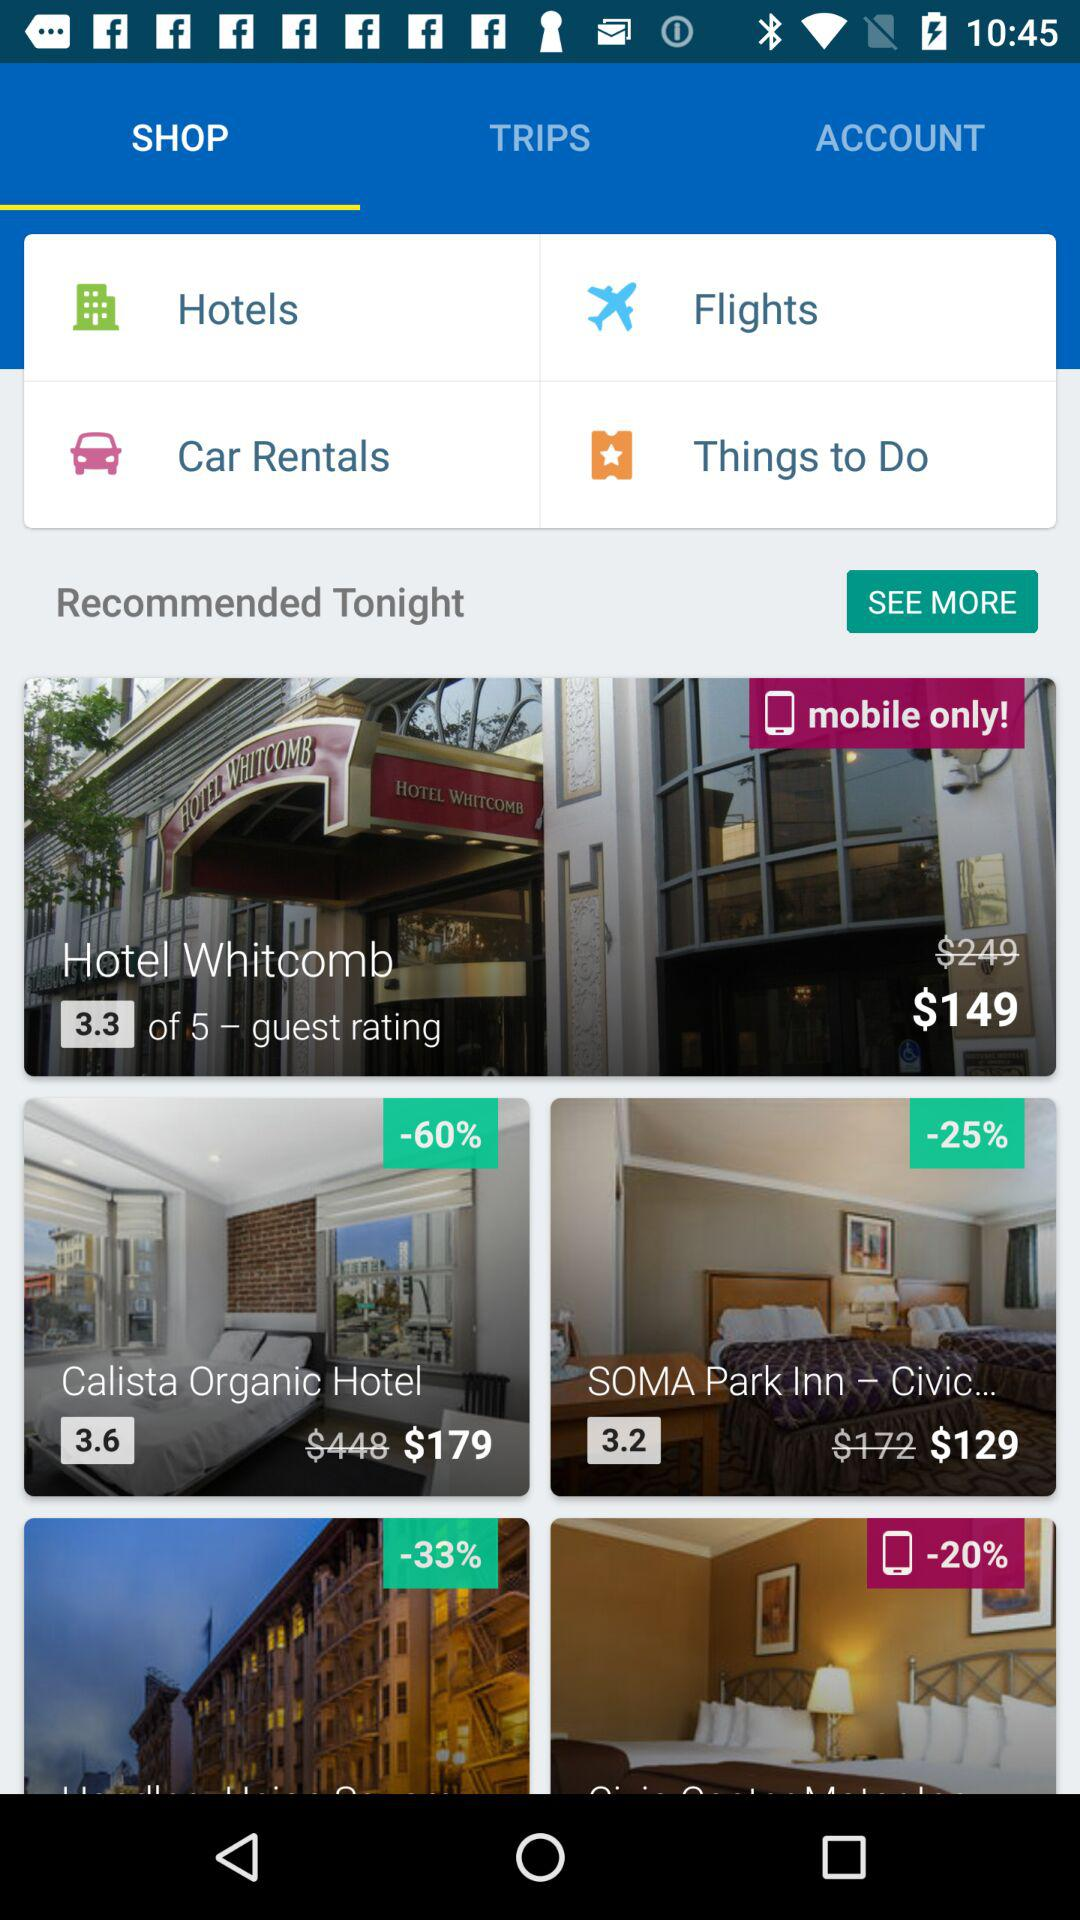What is the name of the hotel having a 60% discount? The name of the hotel is "Calista Organic Hotel". 